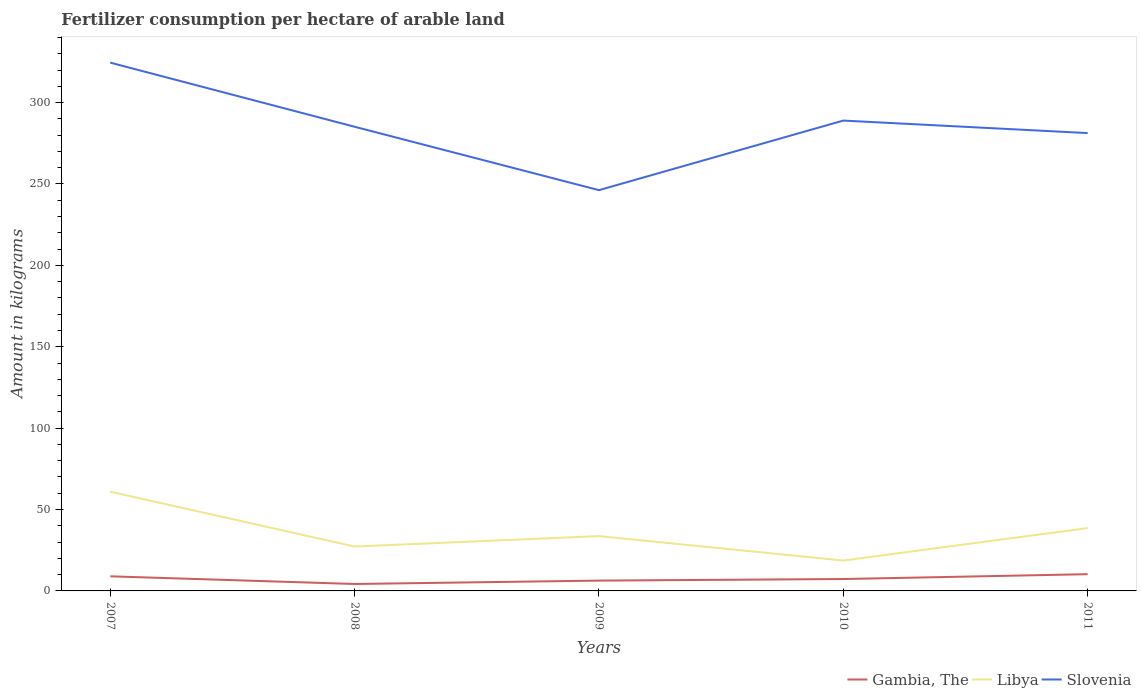Does the line corresponding to Gambia, The intersect with the line corresponding to Slovenia?
Your answer should be very brief. No. Is the number of lines equal to the number of legend labels?
Give a very brief answer. Yes. Across all years, what is the maximum amount of fertilizer consumption in Libya?
Offer a terse response. 18.66. In which year was the amount of fertilizer consumption in Libya maximum?
Your answer should be compact. 2010. What is the total amount of fertilizer consumption in Gambia, The in the graph?
Give a very brief answer. -3.93. What is the difference between the highest and the second highest amount of fertilizer consumption in Libya?
Offer a terse response. 42.3. What is the difference between the highest and the lowest amount of fertilizer consumption in Slovenia?
Give a very brief answer. 2. How many lines are there?
Give a very brief answer. 3. How many years are there in the graph?
Give a very brief answer. 5. Are the values on the major ticks of Y-axis written in scientific E-notation?
Give a very brief answer. No. Does the graph contain any zero values?
Make the answer very short. No. Where does the legend appear in the graph?
Offer a terse response. Bottom right. What is the title of the graph?
Keep it short and to the point. Fertilizer consumption per hectare of arable land. What is the label or title of the X-axis?
Provide a succinct answer. Years. What is the label or title of the Y-axis?
Your answer should be very brief. Amount in kilograms. What is the Amount in kilograms of Gambia, The in 2007?
Your answer should be compact. 8.98. What is the Amount in kilograms of Libya in 2007?
Offer a terse response. 60.96. What is the Amount in kilograms of Slovenia in 2007?
Your answer should be very brief. 324.53. What is the Amount in kilograms in Gambia, The in 2008?
Provide a short and direct response. 4.26. What is the Amount in kilograms of Libya in 2008?
Make the answer very short. 27.27. What is the Amount in kilograms of Slovenia in 2008?
Provide a short and direct response. 285.14. What is the Amount in kilograms of Gambia, The in 2009?
Your answer should be compact. 6.34. What is the Amount in kilograms in Libya in 2009?
Provide a succinct answer. 33.67. What is the Amount in kilograms of Slovenia in 2009?
Your response must be concise. 246.19. What is the Amount in kilograms of Libya in 2010?
Provide a short and direct response. 18.66. What is the Amount in kilograms of Slovenia in 2010?
Your response must be concise. 288.94. What is the Amount in kilograms of Gambia, The in 2011?
Provide a short and direct response. 10.28. What is the Amount in kilograms of Libya in 2011?
Your answer should be very brief. 38.61. What is the Amount in kilograms in Slovenia in 2011?
Your answer should be compact. 281.25. Across all years, what is the maximum Amount in kilograms in Gambia, The?
Provide a succinct answer. 10.28. Across all years, what is the maximum Amount in kilograms of Libya?
Keep it short and to the point. 60.96. Across all years, what is the maximum Amount in kilograms in Slovenia?
Offer a very short reply. 324.53. Across all years, what is the minimum Amount in kilograms of Gambia, The?
Offer a very short reply. 4.26. Across all years, what is the minimum Amount in kilograms of Libya?
Keep it short and to the point. 18.66. Across all years, what is the minimum Amount in kilograms of Slovenia?
Keep it short and to the point. 246.19. What is the total Amount in kilograms in Gambia, The in the graph?
Ensure brevity in your answer.  37.16. What is the total Amount in kilograms in Libya in the graph?
Ensure brevity in your answer.  179.16. What is the total Amount in kilograms of Slovenia in the graph?
Your answer should be very brief. 1426.05. What is the difference between the Amount in kilograms in Gambia, The in 2007 and that in 2008?
Offer a very short reply. 4.72. What is the difference between the Amount in kilograms in Libya in 2007 and that in 2008?
Ensure brevity in your answer.  33.69. What is the difference between the Amount in kilograms in Slovenia in 2007 and that in 2008?
Provide a short and direct response. 39.38. What is the difference between the Amount in kilograms of Gambia, The in 2007 and that in 2009?
Offer a very short reply. 2.63. What is the difference between the Amount in kilograms in Libya in 2007 and that in 2009?
Provide a succinct answer. 27.29. What is the difference between the Amount in kilograms of Slovenia in 2007 and that in 2009?
Make the answer very short. 78.33. What is the difference between the Amount in kilograms of Gambia, The in 2007 and that in 2010?
Make the answer very short. 1.68. What is the difference between the Amount in kilograms in Libya in 2007 and that in 2010?
Offer a very short reply. 42.3. What is the difference between the Amount in kilograms of Slovenia in 2007 and that in 2010?
Ensure brevity in your answer.  35.59. What is the difference between the Amount in kilograms of Gambia, The in 2007 and that in 2011?
Make the answer very short. -1.3. What is the difference between the Amount in kilograms in Libya in 2007 and that in 2011?
Offer a very short reply. 22.35. What is the difference between the Amount in kilograms in Slovenia in 2007 and that in 2011?
Your response must be concise. 43.27. What is the difference between the Amount in kilograms in Gambia, The in 2008 and that in 2009?
Your response must be concise. -2.08. What is the difference between the Amount in kilograms in Libya in 2008 and that in 2009?
Offer a very short reply. -6.4. What is the difference between the Amount in kilograms in Slovenia in 2008 and that in 2009?
Your answer should be very brief. 38.95. What is the difference between the Amount in kilograms in Gambia, The in 2008 and that in 2010?
Your answer should be compact. -3.04. What is the difference between the Amount in kilograms of Libya in 2008 and that in 2010?
Offer a very short reply. 8.61. What is the difference between the Amount in kilograms in Slovenia in 2008 and that in 2010?
Provide a succinct answer. -3.79. What is the difference between the Amount in kilograms in Gambia, The in 2008 and that in 2011?
Your response must be concise. -6.01. What is the difference between the Amount in kilograms of Libya in 2008 and that in 2011?
Give a very brief answer. -11.34. What is the difference between the Amount in kilograms of Slovenia in 2008 and that in 2011?
Provide a succinct answer. 3.89. What is the difference between the Amount in kilograms of Gambia, The in 2009 and that in 2010?
Make the answer very short. -0.96. What is the difference between the Amount in kilograms in Libya in 2009 and that in 2010?
Provide a succinct answer. 15.01. What is the difference between the Amount in kilograms in Slovenia in 2009 and that in 2010?
Give a very brief answer. -42.74. What is the difference between the Amount in kilograms of Gambia, The in 2009 and that in 2011?
Provide a short and direct response. -3.93. What is the difference between the Amount in kilograms in Libya in 2009 and that in 2011?
Provide a succinct answer. -4.94. What is the difference between the Amount in kilograms in Slovenia in 2009 and that in 2011?
Your answer should be very brief. -35.06. What is the difference between the Amount in kilograms in Gambia, The in 2010 and that in 2011?
Offer a very short reply. -2.98. What is the difference between the Amount in kilograms in Libya in 2010 and that in 2011?
Your response must be concise. -19.95. What is the difference between the Amount in kilograms of Slovenia in 2010 and that in 2011?
Give a very brief answer. 7.68. What is the difference between the Amount in kilograms in Gambia, The in 2007 and the Amount in kilograms in Libya in 2008?
Offer a terse response. -18.29. What is the difference between the Amount in kilograms of Gambia, The in 2007 and the Amount in kilograms of Slovenia in 2008?
Provide a short and direct response. -276.17. What is the difference between the Amount in kilograms in Libya in 2007 and the Amount in kilograms in Slovenia in 2008?
Your answer should be compact. -224.18. What is the difference between the Amount in kilograms of Gambia, The in 2007 and the Amount in kilograms of Libya in 2009?
Give a very brief answer. -24.69. What is the difference between the Amount in kilograms in Gambia, The in 2007 and the Amount in kilograms in Slovenia in 2009?
Make the answer very short. -237.22. What is the difference between the Amount in kilograms in Libya in 2007 and the Amount in kilograms in Slovenia in 2009?
Ensure brevity in your answer.  -185.23. What is the difference between the Amount in kilograms of Gambia, The in 2007 and the Amount in kilograms of Libya in 2010?
Your answer should be compact. -9.68. What is the difference between the Amount in kilograms of Gambia, The in 2007 and the Amount in kilograms of Slovenia in 2010?
Give a very brief answer. -279.96. What is the difference between the Amount in kilograms in Libya in 2007 and the Amount in kilograms in Slovenia in 2010?
Offer a terse response. -227.98. What is the difference between the Amount in kilograms of Gambia, The in 2007 and the Amount in kilograms of Libya in 2011?
Keep it short and to the point. -29.63. What is the difference between the Amount in kilograms of Gambia, The in 2007 and the Amount in kilograms of Slovenia in 2011?
Make the answer very short. -272.28. What is the difference between the Amount in kilograms in Libya in 2007 and the Amount in kilograms in Slovenia in 2011?
Offer a terse response. -220.29. What is the difference between the Amount in kilograms of Gambia, The in 2008 and the Amount in kilograms of Libya in 2009?
Keep it short and to the point. -29.41. What is the difference between the Amount in kilograms in Gambia, The in 2008 and the Amount in kilograms in Slovenia in 2009?
Your response must be concise. -241.93. What is the difference between the Amount in kilograms in Libya in 2008 and the Amount in kilograms in Slovenia in 2009?
Give a very brief answer. -218.93. What is the difference between the Amount in kilograms in Gambia, The in 2008 and the Amount in kilograms in Libya in 2010?
Your answer should be compact. -14.4. What is the difference between the Amount in kilograms of Gambia, The in 2008 and the Amount in kilograms of Slovenia in 2010?
Keep it short and to the point. -284.68. What is the difference between the Amount in kilograms in Libya in 2008 and the Amount in kilograms in Slovenia in 2010?
Your answer should be compact. -261.67. What is the difference between the Amount in kilograms in Gambia, The in 2008 and the Amount in kilograms in Libya in 2011?
Provide a succinct answer. -34.35. What is the difference between the Amount in kilograms in Gambia, The in 2008 and the Amount in kilograms in Slovenia in 2011?
Give a very brief answer. -276.99. What is the difference between the Amount in kilograms in Libya in 2008 and the Amount in kilograms in Slovenia in 2011?
Ensure brevity in your answer.  -253.98. What is the difference between the Amount in kilograms of Gambia, The in 2009 and the Amount in kilograms of Libya in 2010?
Your answer should be compact. -12.32. What is the difference between the Amount in kilograms in Gambia, The in 2009 and the Amount in kilograms in Slovenia in 2010?
Keep it short and to the point. -282.59. What is the difference between the Amount in kilograms in Libya in 2009 and the Amount in kilograms in Slovenia in 2010?
Your answer should be compact. -255.27. What is the difference between the Amount in kilograms of Gambia, The in 2009 and the Amount in kilograms of Libya in 2011?
Offer a terse response. -32.26. What is the difference between the Amount in kilograms in Gambia, The in 2009 and the Amount in kilograms in Slovenia in 2011?
Give a very brief answer. -274.91. What is the difference between the Amount in kilograms of Libya in 2009 and the Amount in kilograms of Slovenia in 2011?
Your answer should be very brief. -247.58. What is the difference between the Amount in kilograms of Gambia, The in 2010 and the Amount in kilograms of Libya in 2011?
Provide a short and direct response. -31.31. What is the difference between the Amount in kilograms of Gambia, The in 2010 and the Amount in kilograms of Slovenia in 2011?
Provide a succinct answer. -273.95. What is the difference between the Amount in kilograms of Libya in 2010 and the Amount in kilograms of Slovenia in 2011?
Your answer should be very brief. -262.59. What is the average Amount in kilograms in Gambia, The per year?
Make the answer very short. 7.43. What is the average Amount in kilograms in Libya per year?
Your answer should be compact. 35.83. What is the average Amount in kilograms of Slovenia per year?
Your answer should be very brief. 285.21. In the year 2007, what is the difference between the Amount in kilograms in Gambia, The and Amount in kilograms in Libya?
Your answer should be very brief. -51.98. In the year 2007, what is the difference between the Amount in kilograms of Gambia, The and Amount in kilograms of Slovenia?
Your answer should be very brief. -315.55. In the year 2007, what is the difference between the Amount in kilograms in Libya and Amount in kilograms in Slovenia?
Offer a very short reply. -263.57. In the year 2008, what is the difference between the Amount in kilograms in Gambia, The and Amount in kilograms in Libya?
Keep it short and to the point. -23.01. In the year 2008, what is the difference between the Amount in kilograms in Gambia, The and Amount in kilograms in Slovenia?
Your response must be concise. -280.88. In the year 2008, what is the difference between the Amount in kilograms in Libya and Amount in kilograms in Slovenia?
Provide a succinct answer. -257.88. In the year 2009, what is the difference between the Amount in kilograms in Gambia, The and Amount in kilograms in Libya?
Your response must be concise. -27.33. In the year 2009, what is the difference between the Amount in kilograms in Gambia, The and Amount in kilograms in Slovenia?
Your response must be concise. -239.85. In the year 2009, what is the difference between the Amount in kilograms of Libya and Amount in kilograms of Slovenia?
Your response must be concise. -212.53. In the year 2010, what is the difference between the Amount in kilograms in Gambia, The and Amount in kilograms in Libya?
Provide a succinct answer. -11.36. In the year 2010, what is the difference between the Amount in kilograms in Gambia, The and Amount in kilograms in Slovenia?
Offer a terse response. -281.64. In the year 2010, what is the difference between the Amount in kilograms in Libya and Amount in kilograms in Slovenia?
Make the answer very short. -270.28. In the year 2011, what is the difference between the Amount in kilograms of Gambia, The and Amount in kilograms of Libya?
Ensure brevity in your answer.  -28.33. In the year 2011, what is the difference between the Amount in kilograms of Gambia, The and Amount in kilograms of Slovenia?
Keep it short and to the point. -270.98. In the year 2011, what is the difference between the Amount in kilograms in Libya and Amount in kilograms in Slovenia?
Provide a short and direct response. -242.65. What is the ratio of the Amount in kilograms in Gambia, The in 2007 to that in 2008?
Give a very brief answer. 2.11. What is the ratio of the Amount in kilograms of Libya in 2007 to that in 2008?
Your answer should be compact. 2.24. What is the ratio of the Amount in kilograms in Slovenia in 2007 to that in 2008?
Ensure brevity in your answer.  1.14. What is the ratio of the Amount in kilograms in Gambia, The in 2007 to that in 2009?
Ensure brevity in your answer.  1.42. What is the ratio of the Amount in kilograms in Libya in 2007 to that in 2009?
Your answer should be compact. 1.81. What is the ratio of the Amount in kilograms of Slovenia in 2007 to that in 2009?
Your answer should be compact. 1.32. What is the ratio of the Amount in kilograms in Gambia, The in 2007 to that in 2010?
Your response must be concise. 1.23. What is the ratio of the Amount in kilograms in Libya in 2007 to that in 2010?
Offer a terse response. 3.27. What is the ratio of the Amount in kilograms of Slovenia in 2007 to that in 2010?
Your answer should be compact. 1.12. What is the ratio of the Amount in kilograms in Gambia, The in 2007 to that in 2011?
Offer a very short reply. 0.87. What is the ratio of the Amount in kilograms of Libya in 2007 to that in 2011?
Provide a short and direct response. 1.58. What is the ratio of the Amount in kilograms in Slovenia in 2007 to that in 2011?
Make the answer very short. 1.15. What is the ratio of the Amount in kilograms in Gambia, The in 2008 to that in 2009?
Make the answer very short. 0.67. What is the ratio of the Amount in kilograms in Libya in 2008 to that in 2009?
Offer a very short reply. 0.81. What is the ratio of the Amount in kilograms of Slovenia in 2008 to that in 2009?
Your answer should be compact. 1.16. What is the ratio of the Amount in kilograms of Gambia, The in 2008 to that in 2010?
Your answer should be compact. 0.58. What is the ratio of the Amount in kilograms of Libya in 2008 to that in 2010?
Make the answer very short. 1.46. What is the ratio of the Amount in kilograms of Slovenia in 2008 to that in 2010?
Your answer should be compact. 0.99. What is the ratio of the Amount in kilograms of Gambia, The in 2008 to that in 2011?
Your answer should be very brief. 0.41. What is the ratio of the Amount in kilograms of Libya in 2008 to that in 2011?
Your response must be concise. 0.71. What is the ratio of the Amount in kilograms of Slovenia in 2008 to that in 2011?
Your answer should be compact. 1.01. What is the ratio of the Amount in kilograms of Gambia, The in 2009 to that in 2010?
Ensure brevity in your answer.  0.87. What is the ratio of the Amount in kilograms in Libya in 2009 to that in 2010?
Your answer should be compact. 1.8. What is the ratio of the Amount in kilograms in Slovenia in 2009 to that in 2010?
Provide a short and direct response. 0.85. What is the ratio of the Amount in kilograms in Gambia, The in 2009 to that in 2011?
Provide a succinct answer. 0.62. What is the ratio of the Amount in kilograms in Libya in 2009 to that in 2011?
Ensure brevity in your answer.  0.87. What is the ratio of the Amount in kilograms in Slovenia in 2009 to that in 2011?
Your answer should be compact. 0.88. What is the ratio of the Amount in kilograms in Gambia, The in 2010 to that in 2011?
Offer a terse response. 0.71. What is the ratio of the Amount in kilograms of Libya in 2010 to that in 2011?
Your answer should be very brief. 0.48. What is the ratio of the Amount in kilograms of Slovenia in 2010 to that in 2011?
Keep it short and to the point. 1.03. What is the difference between the highest and the second highest Amount in kilograms of Gambia, The?
Keep it short and to the point. 1.3. What is the difference between the highest and the second highest Amount in kilograms of Libya?
Keep it short and to the point. 22.35. What is the difference between the highest and the second highest Amount in kilograms in Slovenia?
Offer a very short reply. 35.59. What is the difference between the highest and the lowest Amount in kilograms in Gambia, The?
Your answer should be compact. 6.01. What is the difference between the highest and the lowest Amount in kilograms in Libya?
Ensure brevity in your answer.  42.3. What is the difference between the highest and the lowest Amount in kilograms in Slovenia?
Ensure brevity in your answer.  78.33. 